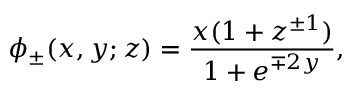Convert formula to latex. <formula><loc_0><loc_0><loc_500><loc_500>\phi _ { \pm } ( x , y ; z ) = \frac { x ( 1 + z ^ { \pm 1 } ) } { 1 + e ^ { \mp 2 y } } ,</formula> 